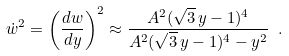Convert formula to latex. <formula><loc_0><loc_0><loc_500><loc_500>\dot { w } ^ { 2 } = \left ( \frac { d w } { d y } \right ) ^ { 2 } \approx \frac { A ^ { 2 } ( \sqrt { 3 } \, y - 1 ) ^ { 4 } } { A ^ { 2 } ( \sqrt { 3 } \, y - 1 ) ^ { 4 } - y ^ { 2 } } \ .</formula> 